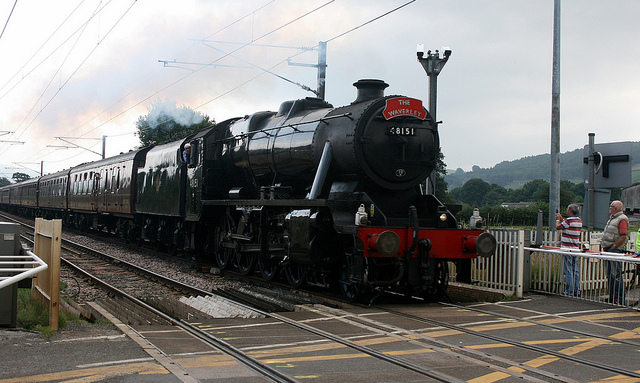Extract all visible text content from this image. 48151 